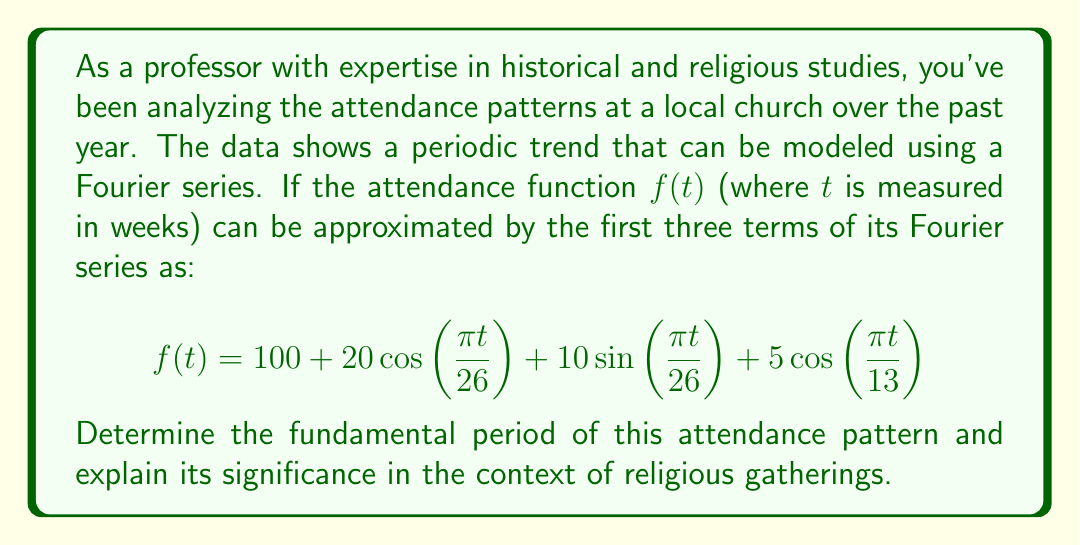Can you answer this question? To solve this problem, we need to analyze the Fourier series representation of the attendance function:

1) The general form of a Fourier series is:

   $$f(t) = a_0 + \sum_{n=1}^{\infty} [a_n\cos(\frac{2\pi nt}{T}) + b_n\sin(\frac{2\pi nt}{T})]$$

   where $T$ is the fundamental period.

2) In our given function:
   
   $$f(t) = 100 + 20\cos(\frac{\pi t}{26}) + 10\sin(\frac{\pi t}{26}) + 5\cos(\frac{\pi t}{13})$$

3) Comparing this with the general form, we can see that:
   
   $\frac{2\pi}{T} = \frac{\pi}{26}$

4) Solving for $T$:
   
   $T = \frac{2\pi}{\frac{\pi}{26}} = 52$ weeks

5) The fundamental period is 52 weeks, which is equivalent to one year.

6) The significance in the context of religious gatherings:
   - This period aligns with the annual cycle of many religious calendars.
   - It suggests that attendance patterns repeat yearly, possibly influenced by:
     a) Major religious holidays (e.g., Easter, Christmas for Christian churches)
     b) Seasonal variations (e.g., summer vacations, winter holidays)
     c) Annual events or programs in the church's schedule

7) The other terms in the Fourier series represent:
   - $\cos(\frac{\pi t}{26})$ and $\sin(\frac{\pi t}{26})$: Semi-annual variations (every 26 weeks)
   - $\cos(\frac{\pi t}{13})$: Quarterly variations (every 13 weeks)

These additional terms capture finer variations within the annual cycle, such as seasonal changes or quarterly church events.
Answer: The fundamental period of the attendance pattern is 52 weeks (1 year). This reflects the annual cycle of religious gatherings, likely influenced by yearly religious holidays, seasonal variations, and recurring church events. 